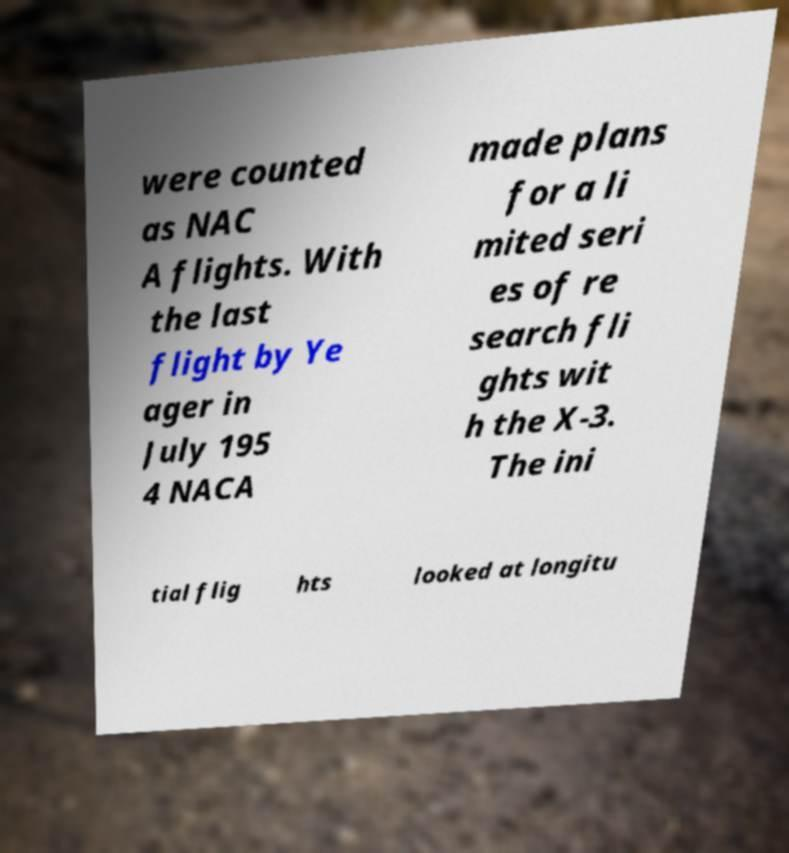There's text embedded in this image that I need extracted. Can you transcribe it verbatim? were counted as NAC A flights. With the last flight by Ye ager in July 195 4 NACA made plans for a li mited seri es of re search fli ghts wit h the X-3. The ini tial flig hts looked at longitu 